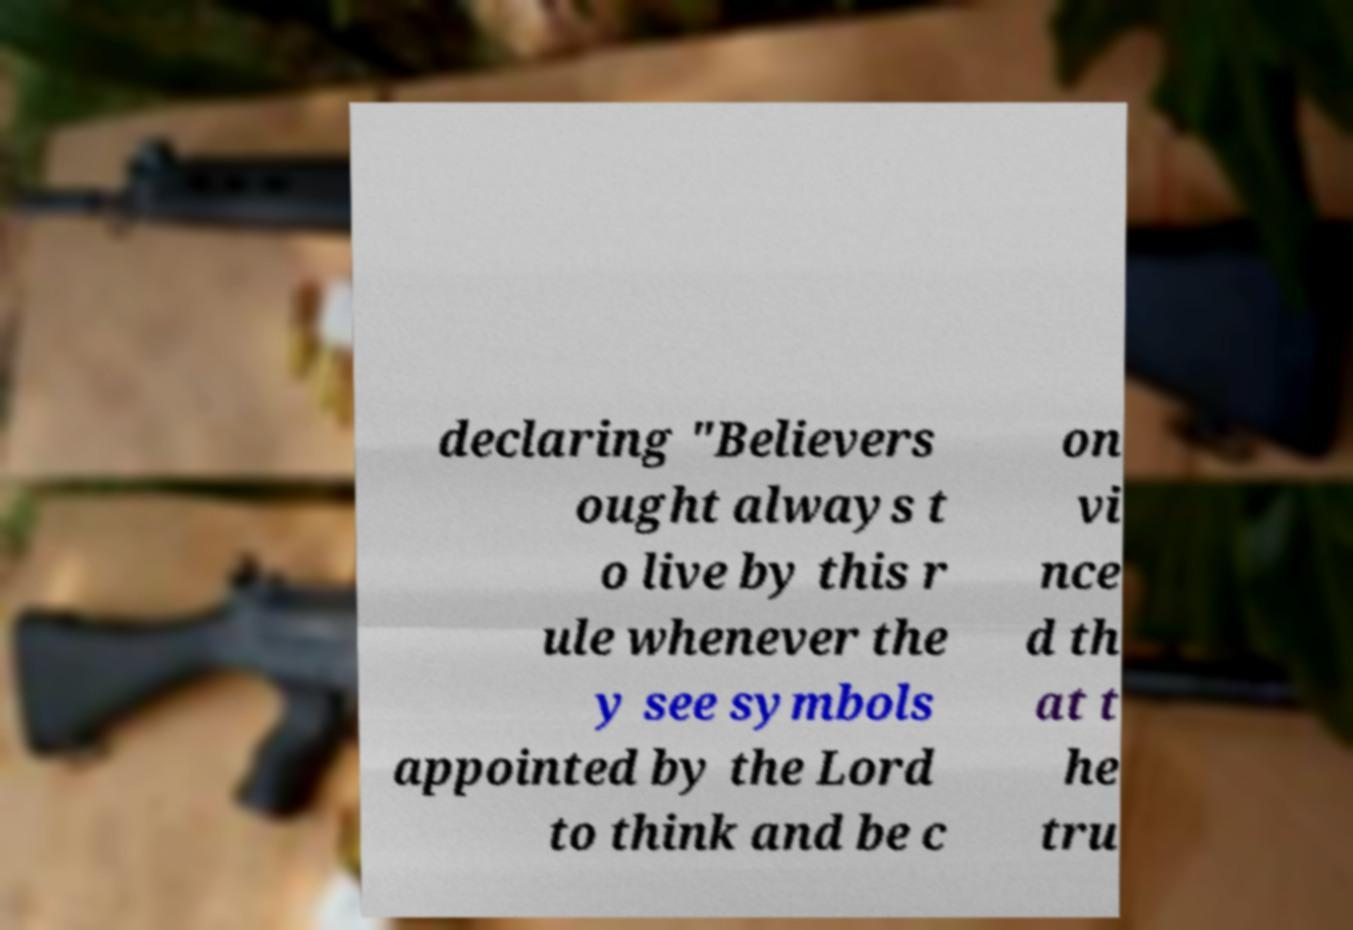Please read and relay the text visible in this image. What does it say? declaring "Believers ought always t o live by this r ule whenever the y see symbols appointed by the Lord to think and be c on vi nce d th at t he tru 